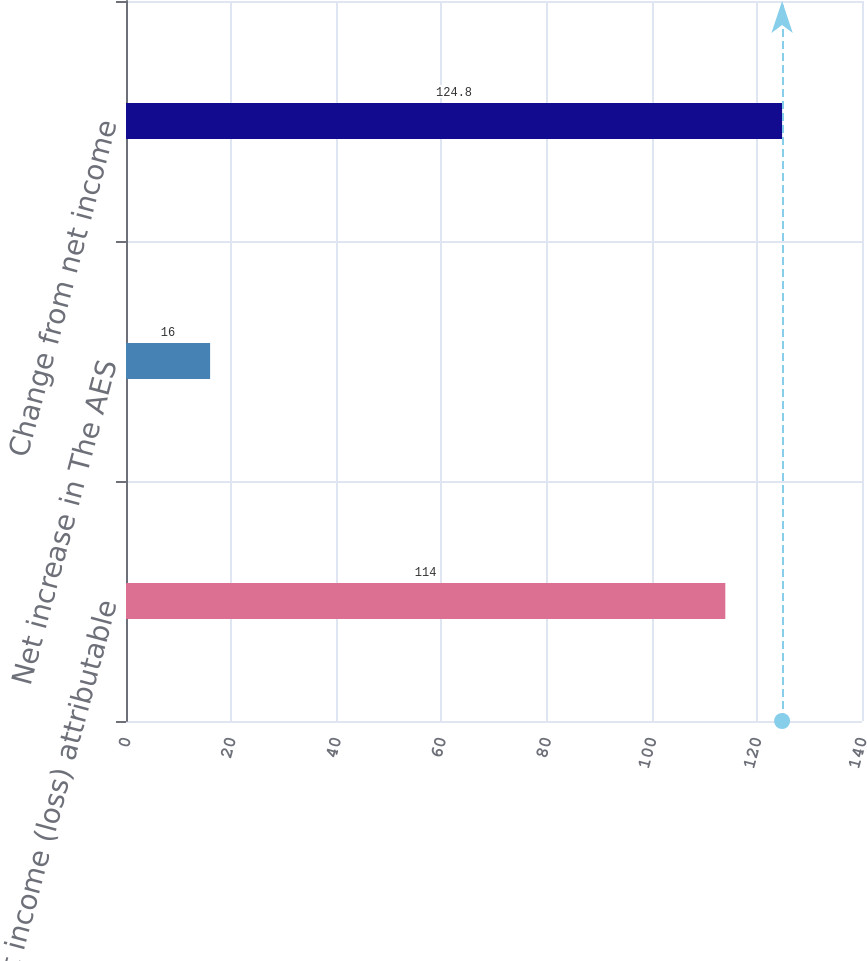Convert chart. <chart><loc_0><loc_0><loc_500><loc_500><bar_chart><fcel>Net income (loss) attributable<fcel>Net increase in The AES<fcel>Change from net income<nl><fcel>114<fcel>16<fcel>124.8<nl></chart> 